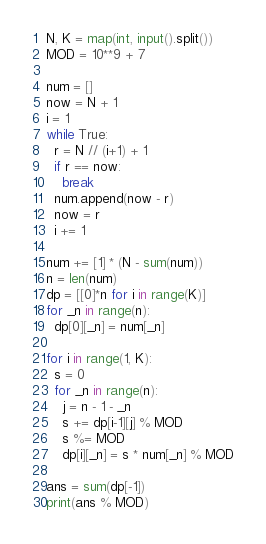<code> <loc_0><loc_0><loc_500><loc_500><_Python_>N, K = map(int, input().split())
MOD = 10**9 + 7

num = []
now = N + 1
i = 1
while True:
  r = N // (i+1) + 1
  if r == now:
    break
  num.append(now - r)
  now = r
  i += 1
  
num += [1] * (N - sum(num))
n = len(num)
dp = [[0]*n for i in range(K)]
for _n in range(n):
  dp[0][_n] = num[_n]

for i in range(1, K):
  s = 0
  for _n in range(n):
    j = n - 1 - _n
    s += dp[i-1][j] % MOD
    s %= MOD
    dp[i][_n] = s * num[_n] % MOD

ans = sum(dp[-1])
print(ans % MOD)</code> 